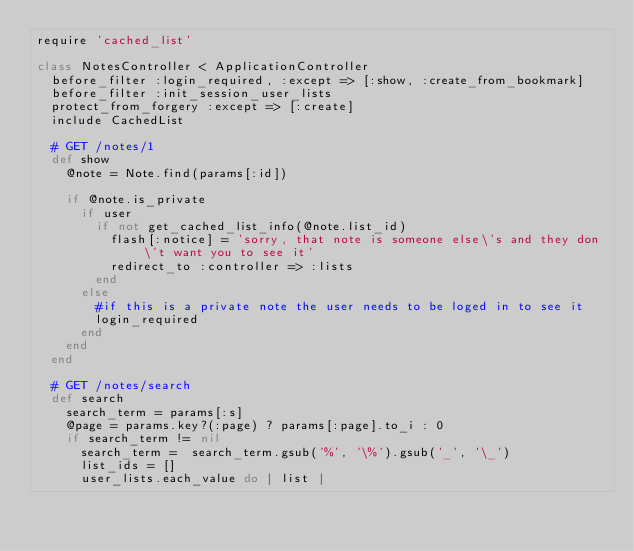<code> <loc_0><loc_0><loc_500><loc_500><_Ruby_>require 'cached_list'

class NotesController < ApplicationController
  before_filter :login_required, :except => [:show, :create_from_bookmark]
  before_filter :init_session_user_lists
  protect_from_forgery :except => [:create]
  include CachedList

  # GET /notes/1
  def show
    @note = Note.find(params[:id])

    if @note.is_private
      if user
        if not get_cached_list_info(@note.list_id)
          flash[:notice] = 'sorry, that note is someone else\'s and they don\'t want you to see it'
          redirect_to :controller => :lists
        end
      else
        #if this is a private note the user needs to be loged in to see it
        login_required
      end
    end
  end

  # GET /notes/search
  def search
    search_term = params[:s]
    @page = params.key?(:page) ? params[:page].to_i : 0
    if search_term != nil
      search_term =  search_term.gsub('%', '\%').gsub('_', '\_')
      list_ids = []
      user_lists.each_value do | list |</code> 